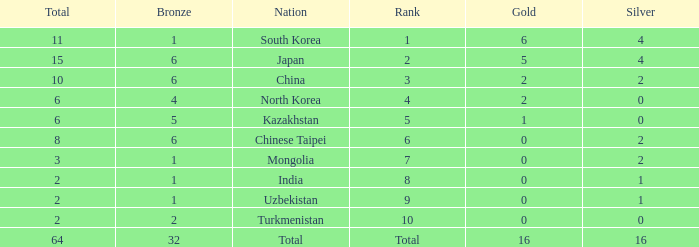What's the biggest Bronze that has less than 0 Silvers? None. Help me parse the entirety of this table. {'header': ['Total', 'Bronze', 'Nation', 'Rank', 'Gold', 'Silver'], 'rows': [['11', '1', 'South Korea', '1', '6', '4'], ['15', '6', 'Japan', '2', '5', '4'], ['10', '6', 'China', '3', '2', '2'], ['6', '4', 'North Korea', '4', '2', '0'], ['6', '5', 'Kazakhstan', '5', '1', '0'], ['8', '6', 'Chinese Taipei', '6', '0', '2'], ['3', '1', 'Mongolia', '7', '0', '2'], ['2', '1', 'India', '8', '0', '1'], ['2', '1', 'Uzbekistan', '9', '0', '1'], ['2', '2', 'Turkmenistan', '10', '0', '0'], ['64', '32', 'Total', 'Total', '16', '16']]} 